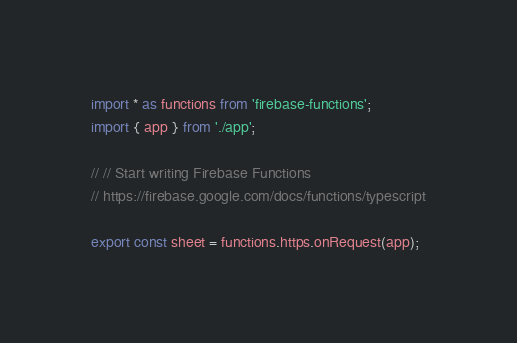Convert code to text. <code><loc_0><loc_0><loc_500><loc_500><_TypeScript_>import * as functions from 'firebase-functions';
import { app } from './app';

// // Start writing Firebase Functions
// https://firebase.google.com/docs/functions/typescript

export const sheet = functions.https.onRequest(app);
</code> 